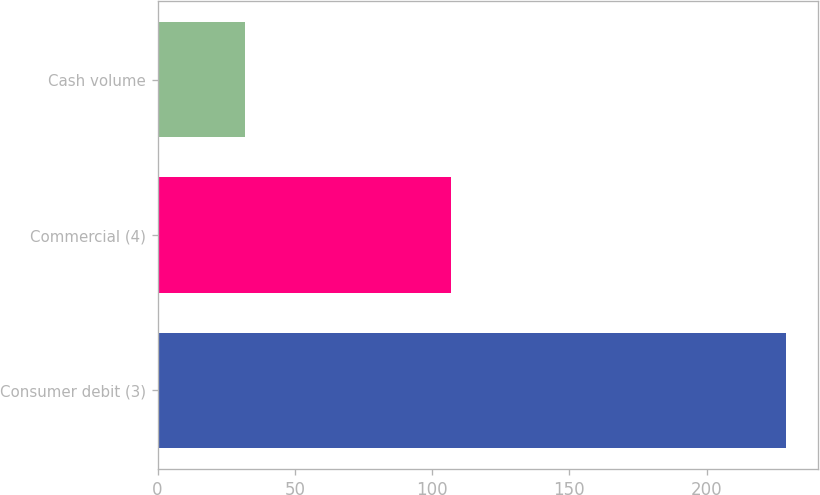Convert chart. <chart><loc_0><loc_0><loc_500><loc_500><bar_chart><fcel>Consumer debit (3)<fcel>Commercial (4)<fcel>Cash volume<nl><fcel>229<fcel>107<fcel>32<nl></chart> 